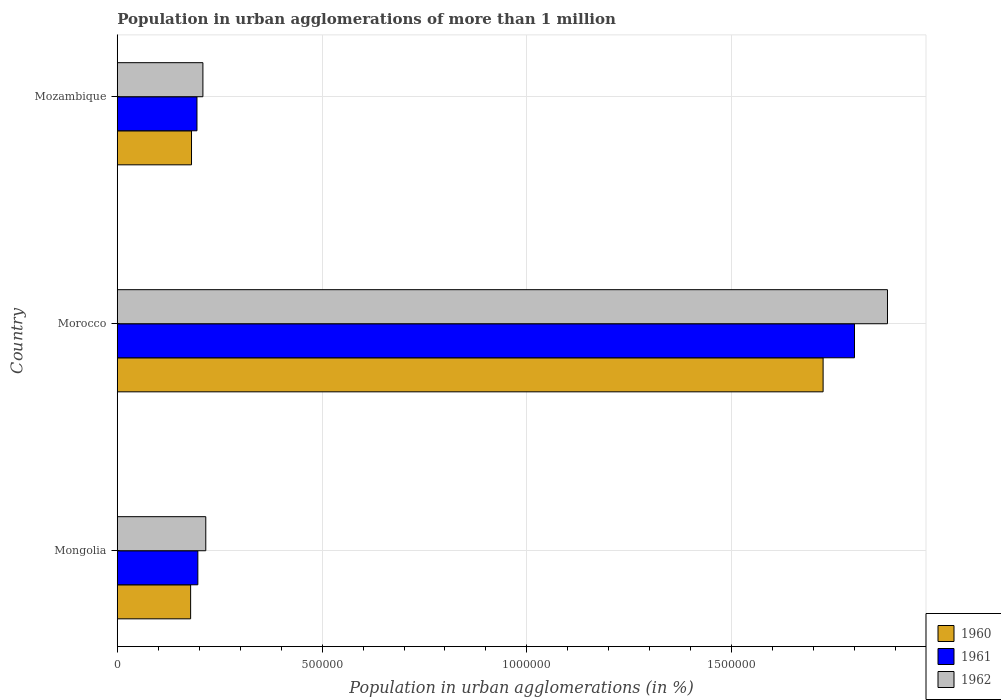How many different coloured bars are there?
Offer a terse response. 3. Are the number of bars per tick equal to the number of legend labels?
Keep it short and to the point. Yes. How many bars are there on the 1st tick from the top?
Your answer should be compact. 3. What is the label of the 1st group of bars from the top?
Offer a terse response. Mozambique. What is the population in urban agglomerations in 1961 in Mongolia?
Provide a succinct answer. 1.97e+05. Across all countries, what is the maximum population in urban agglomerations in 1961?
Ensure brevity in your answer.  1.80e+06. Across all countries, what is the minimum population in urban agglomerations in 1961?
Give a very brief answer. 1.95e+05. In which country was the population in urban agglomerations in 1961 maximum?
Make the answer very short. Morocco. In which country was the population in urban agglomerations in 1960 minimum?
Offer a terse response. Mongolia. What is the total population in urban agglomerations in 1961 in the graph?
Keep it short and to the point. 2.19e+06. What is the difference between the population in urban agglomerations in 1961 in Mongolia and that in Morocco?
Ensure brevity in your answer.  -1.60e+06. What is the difference between the population in urban agglomerations in 1961 in Morocco and the population in urban agglomerations in 1962 in Mozambique?
Your answer should be very brief. 1.59e+06. What is the average population in urban agglomerations in 1962 per country?
Offer a very short reply. 7.69e+05. What is the difference between the population in urban agglomerations in 1962 and population in urban agglomerations in 1961 in Morocco?
Make the answer very short. 8.05e+04. What is the ratio of the population in urban agglomerations in 1961 in Mongolia to that in Mozambique?
Offer a terse response. 1.01. What is the difference between the highest and the second highest population in urban agglomerations in 1960?
Your answer should be compact. 1.54e+06. What is the difference between the highest and the lowest population in urban agglomerations in 1962?
Give a very brief answer. 1.67e+06. Is the sum of the population in urban agglomerations in 1962 in Mongolia and Morocco greater than the maximum population in urban agglomerations in 1960 across all countries?
Offer a very short reply. Yes. What does the 3rd bar from the top in Mongolia represents?
Provide a succinct answer. 1960. Does the graph contain any zero values?
Provide a short and direct response. No. How many legend labels are there?
Provide a succinct answer. 3. How are the legend labels stacked?
Your response must be concise. Vertical. What is the title of the graph?
Offer a very short reply. Population in urban agglomerations of more than 1 million. Does "2001" appear as one of the legend labels in the graph?
Give a very brief answer. No. What is the label or title of the X-axis?
Provide a succinct answer. Population in urban agglomerations (in %). What is the label or title of the Y-axis?
Give a very brief answer. Country. What is the Population in urban agglomerations (in %) in 1960 in Mongolia?
Your response must be concise. 1.79e+05. What is the Population in urban agglomerations (in %) of 1961 in Mongolia?
Provide a short and direct response. 1.97e+05. What is the Population in urban agglomerations (in %) in 1962 in Mongolia?
Offer a terse response. 2.16e+05. What is the Population in urban agglomerations (in %) of 1960 in Morocco?
Provide a short and direct response. 1.72e+06. What is the Population in urban agglomerations (in %) in 1961 in Morocco?
Ensure brevity in your answer.  1.80e+06. What is the Population in urban agglomerations (in %) in 1962 in Morocco?
Provide a short and direct response. 1.88e+06. What is the Population in urban agglomerations (in %) of 1960 in Mozambique?
Your response must be concise. 1.81e+05. What is the Population in urban agglomerations (in %) in 1961 in Mozambique?
Keep it short and to the point. 1.95e+05. What is the Population in urban agglomerations (in %) of 1962 in Mozambique?
Provide a succinct answer. 2.09e+05. Across all countries, what is the maximum Population in urban agglomerations (in %) of 1960?
Make the answer very short. 1.72e+06. Across all countries, what is the maximum Population in urban agglomerations (in %) in 1961?
Ensure brevity in your answer.  1.80e+06. Across all countries, what is the maximum Population in urban agglomerations (in %) of 1962?
Offer a very short reply. 1.88e+06. Across all countries, what is the minimum Population in urban agglomerations (in %) of 1960?
Your response must be concise. 1.79e+05. Across all countries, what is the minimum Population in urban agglomerations (in %) in 1961?
Your response must be concise. 1.95e+05. Across all countries, what is the minimum Population in urban agglomerations (in %) of 1962?
Your answer should be very brief. 2.09e+05. What is the total Population in urban agglomerations (in %) in 1960 in the graph?
Make the answer very short. 2.08e+06. What is the total Population in urban agglomerations (in %) in 1961 in the graph?
Provide a succinct answer. 2.19e+06. What is the total Population in urban agglomerations (in %) in 1962 in the graph?
Ensure brevity in your answer.  2.31e+06. What is the difference between the Population in urban agglomerations (in %) of 1960 in Mongolia and that in Morocco?
Give a very brief answer. -1.54e+06. What is the difference between the Population in urban agglomerations (in %) of 1961 in Mongolia and that in Morocco?
Make the answer very short. -1.60e+06. What is the difference between the Population in urban agglomerations (in %) in 1962 in Mongolia and that in Morocco?
Keep it short and to the point. -1.66e+06. What is the difference between the Population in urban agglomerations (in %) of 1960 in Mongolia and that in Mozambique?
Ensure brevity in your answer.  -2160. What is the difference between the Population in urban agglomerations (in %) in 1961 in Mongolia and that in Mozambique?
Provide a short and direct response. 2138. What is the difference between the Population in urban agglomerations (in %) of 1962 in Mongolia and that in Mozambique?
Ensure brevity in your answer.  7029. What is the difference between the Population in urban agglomerations (in %) in 1960 in Morocco and that in Mozambique?
Give a very brief answer. 1.54e+06. What is the difference between the Population in urban agglomerations (in %) of 1961 in Morocco and that in Mozambique?
Your response must be concise. 1.61e+06. What is the difference between the Population in urban agglomerations (in %) of 1962 in Morocco and that in Mozambique?
Offer a very short reply. 1.67e+06. What is the difference between the Population in urban agglomerations (in %) of 1960 in Mongolia and the Population in urban agglomerations (in %) of 1961 in Morocco?
Your response must be concise. -1.62e+06. What is the difference between the Population in urban agglomerations (in %) in 1960 in Mongolia and the Population in urban agglomerations (in %) in 1962 in Morocco?
Your answer should be very brief. -1.70e+06. What is the difference between the Population in urban agglomerations (in %) in 1961 in Mongolia and the Population in urban agglomerations (in %) in 1962 in Morocco?
Give a very brief answer. -1.68e+06. What is the difference between the Population in urban agglomerations (in %) of 1960 in Mongolia and the Population in urban agglomerations (in %) of 1961 in Mozambique?
Your answer should be very brief. -1.55e+04. What is the difference between the Population in urban agglomerations (in %) of 1960 in Mongolia and the Population in urban agglomerations (in %) of 1962 in Mozambique?
Offer a very short reply. -3.00e+04. What is the difference between the Population in urban agglomerations (in %) in 1961 in Mongolia and the Population in urban agglomerations (in %) in 1962 in Mozambique?
Provide a succinct answer. -1.24e+04. What is the difference between the Population in urban agglomerations (in %) of 1960 in Morocco and the Population in urban agglomerations (in %) of 1961 in Mozambique?
Ensure brevity in your answer.  1.53e+06. What is the difference between the Population in urban agglomerations (in %) of 1960 in Morocco and the Population in urban agglomerations (in %) of 1962 in Mozambique?
Your answer should be very brief. 1.51e+06. What is the difference between the Population in urban agglomerations (in %) in 1961 in Morocco and the Population in urban agglomerations (in %) in 1962 in Mozambique?
Make the answer very short. 1.59e+06. What is the average Population in urban agglomerations (in %) of 1960 per country?
Your answer should be very brief. 6.95e+05. What is the average Population in urban agglomerations (in %) of 1961 per country?
Provide a succinct answer. 7.30e+05. What is the average Population in urban agglomerations (in %) in 1962 per country?
Offer a very short reply. 7.69e+05. What is the difference between the Population in urban agglomerations (in %) of 1960 and Population in urban agglomerations (in %) of 1961 in Mongolia?
Offer a very short reply. -1.76e+04. What is the difference between the Population in urban agglomerations (in %) in 1960 and Population in urban agglomerations (in %) in 1962 in Mongolia?
Provide a short and direct response. -3.70e+04. What is the difference between the Population in urban agglomerations (in %) of 1961 and Population in urban agglomerations (in %) of 1962 in Mongolia?
Your answer should be very brief. -1.94e+04. What is the difference between the Population in urban agglomerations (in %) of 1960 and Population in urban agglomerations (in %) of 1961 in Morocco?
Make the answer very short. -7.66e+04. What is the difference between the Population in urban agglomerations (in %) of 1960 and Population in urban agglomerations (in %) of 1962 in Morocco?
Give a very brief answer. -1.57e+05. What is the difference between the Population in urban agglomerations (in %) of 1961 and Population in urban agglomerations (in %) of 1962 in Morocco?
Keep it short and to the point. -8.05e+04. What is the difference between the Population in urban agglomerations (in %) in 1960 and Population in urban agglomerations (in %) in 1961 in Mozambique?
Ensure brevity in your answer.  -1.33e+04. What is the difference between the Population in urban agglomerations (in %) of 1960 and Population in urban agglomerations (in %) of 1962 in Mozambique?
Your answer should be very brief. -2.78e+04. What is the difference between the Population in urban agglomerations (in %) in 1961 and Population in urban agglomerations (in %) in 1962 in Mozambique?
Offer a terse response. -1.45e+04. What is the ratio of the Population in urban agglomerations (in %) of 1960 in Mongolia to that in Morocco?
Ensure brevity in your answer.  0.1. What is the ratio of the Population in urban agglomerations (in %) of 1961 in Mongolia to that in Morocco?
Offer a very short reply. 0.11. What is the ratio of the Population in urban agglomerations (in %) of 1962 in Mongolia to that in Morocco?
Keep it short and to the point. 0.11. What is the ratio of the Population in urban agglomerations (in %) in 1960 in Mongolia to that in Mozambique?
Keep it short and to the point. 0.99. What is the ratio of the Population in urban agglomerations (in %) in 1961 in Mongolia to that in Mozambique?
Make the answer very short. 1.01. What is the ratio of the Population in urban agglomerations (in %) in 1962 in Mongolia to that in Mozambique?
Your answer should be compact. 1.03. What is the ratio of the Population in urban agglomerations (in %) in 1960 in Morocco to that in Mozambique?
Your answer should be compact. 9.51. What is the ratio of the Population in urban agglomerations (in %) in 1961 in Morocco to that in Mozambique?
Your answer should be compact. 9.25. What is the ratio of the Population in urban agglomerations (in %) of 1962 in Morocco to that in Mozambique?
Keep it short and to the point. 9. What is the difference between the highest and the second highest Population in urban agglomerations (in %) of 1960?
Ensure brevity in your answer.  1.54e+06. What is the difference between the highest and the second highest Population in urban agglomerations (in %) in 1961?
Ensure brevity in your answer.  1.60e+06. What is the difference between the highest and the second highest Population in urban agglomerations (in %) in 1962?
Your response must be concise. 1.66e+06. What is the difference between the highest and the lowest Population in urban agglomerations (in %) of 1960?
Offer a terse response. 1.54e+06. What is the difference between the highest and the lowest Population in urban agglomerations (in %) of 1961?
Ensure brevity in your answer.  1.61e+06. What is the difference between the highest and the lowest Population in urban agglomerations (in %) in 1962?
Give a very brief answer. 1.67e+06. 